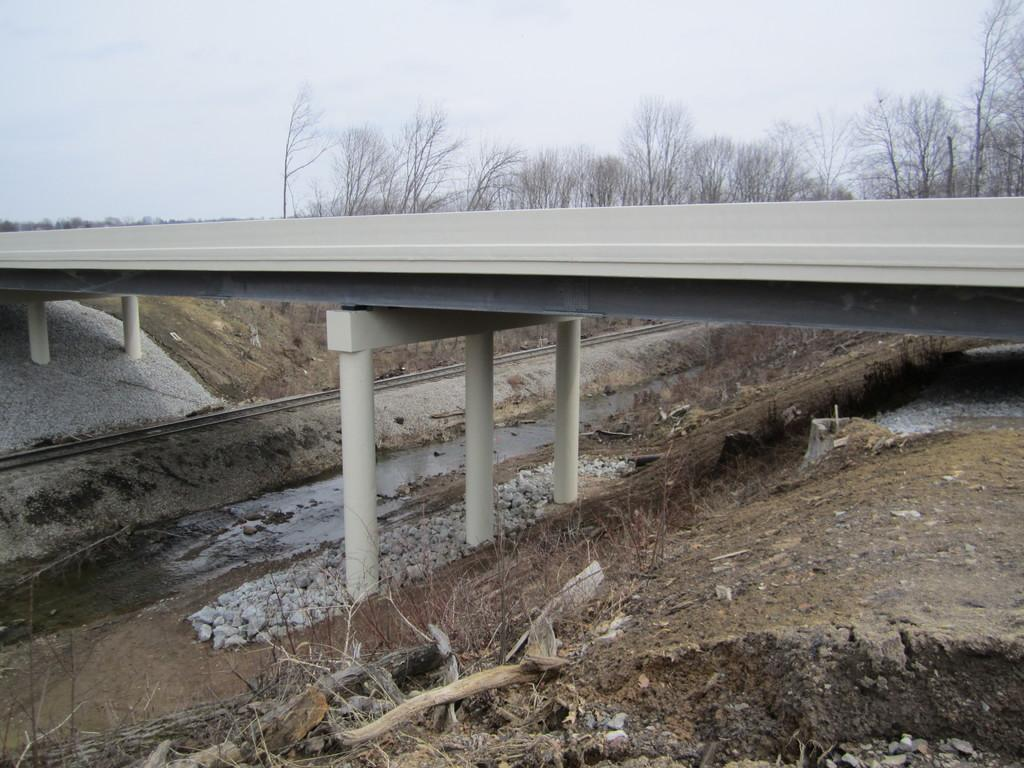What structure is present in the image that allows people or vehicles to cross over something? There is a bridge in the image that serves this purpose. What is the bridge positioned over? The bridge is over a railway track. What type of natural elements can be seen in the image? There are stones, trees, and plants visible in the image. What other objects can be seen in the image? There are wooden sticks present in the image. What is visible in the background of the image? The sky is visible in the image. What type of cushion can be seen supporting the wooden sticks in the image? There is no cushion present in the image, nor are any wooden sticks being supported by one. 